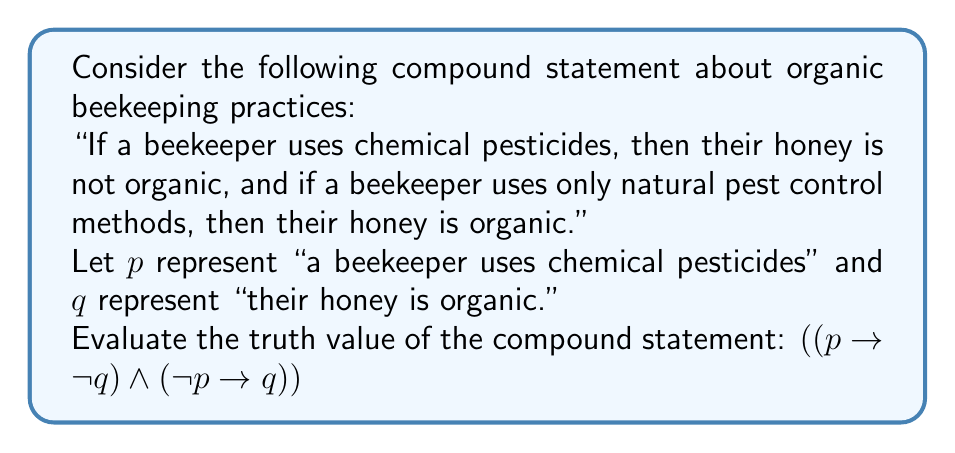Provide a solution to this math problem. To evaluate the truth value of this compound statement, we need to break it down into its components and use a truth table:

1. First, let's identify the components:
   - $p \rightarrow \neg q$
   - $\neg p \rightarrow q$
   - The main connective is $\wedge$ (AND)

2. Create a truth table for all possible combinations of $p$ and $q$:

   | $p$ | $q$ | $\neg q$ | $\neg p$ | $p \rightarrow \neg q$ | $\neg p \rightarrow q$ | $(p \rightarrow \neg q) \wedge (\neg p \rightarrow q)$ |
   |-----|-----|----------|----------|------------------------|------------------------|-------------------------------------------------------|
   | T   | T   | F        | F        | F                      | T                      | F                                                     |
   | T   | F   | T        | F        | T                      | T                      | T                                                     |
   | F   | T   | F        | T        | T                      | T                      | T                                                     |
   | F   | F   | T        | T        | T                      | F                      | F                                                     |

3. Evaluate each component:
   - For $p \rightarrow \neg q$: This is false only when $p$ is true and $\neg q$ is false (i.e., when $p$ is true and $q$ is true).
   - For $\neg p \rightarrow q$: This is false only when $\neg p$ is true and $q$ is false (i.e., when $p$ is false and $q$ is false).

4. Combine the results using the main connective $\wedge$:
   The compound statement is true only when both components are true, which occurs in two cases:
   - When $p$ is true and $q$ is false
   - When $p$ is false and $q$ is true

5. Interpret the result:
   The compound statement is true in situations where either:
   - A beekeeper uses chemical pesticides and their honey is not organic, or
   - A beekeeper does not use chemical pesticides and their honey is organic

   However, it is false in cases where:
   - A beekeeper uses chemical pesticides and their honey is still considered organic, or
   - A beekeeper does not use chemical pesticides, but their honey is not considered organic

Therefore, the compound statement is not a tautology (always true) but a contingency (sometimes true, sometimes false).
Answer: The compound statement $((p \rightarrow \neg q) \wedge (\neg p \rightarrow q))$ is a contingency, meaning its truth value depends on the specific values of $p$ and $q$. It is true in some cases and false in others, as shown in the truth table. 